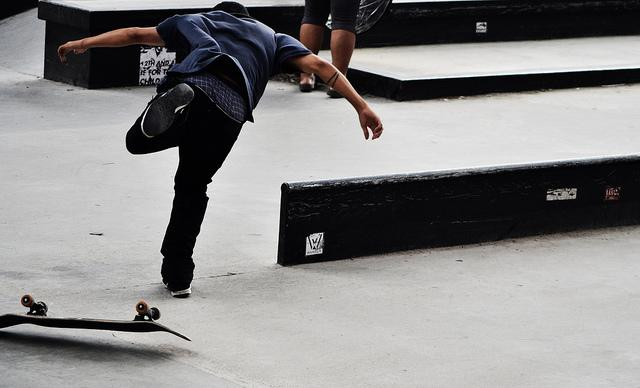How he is going to get hurt?

Choices:
A) flying
B) beaten
C) shot
D) falling falling 